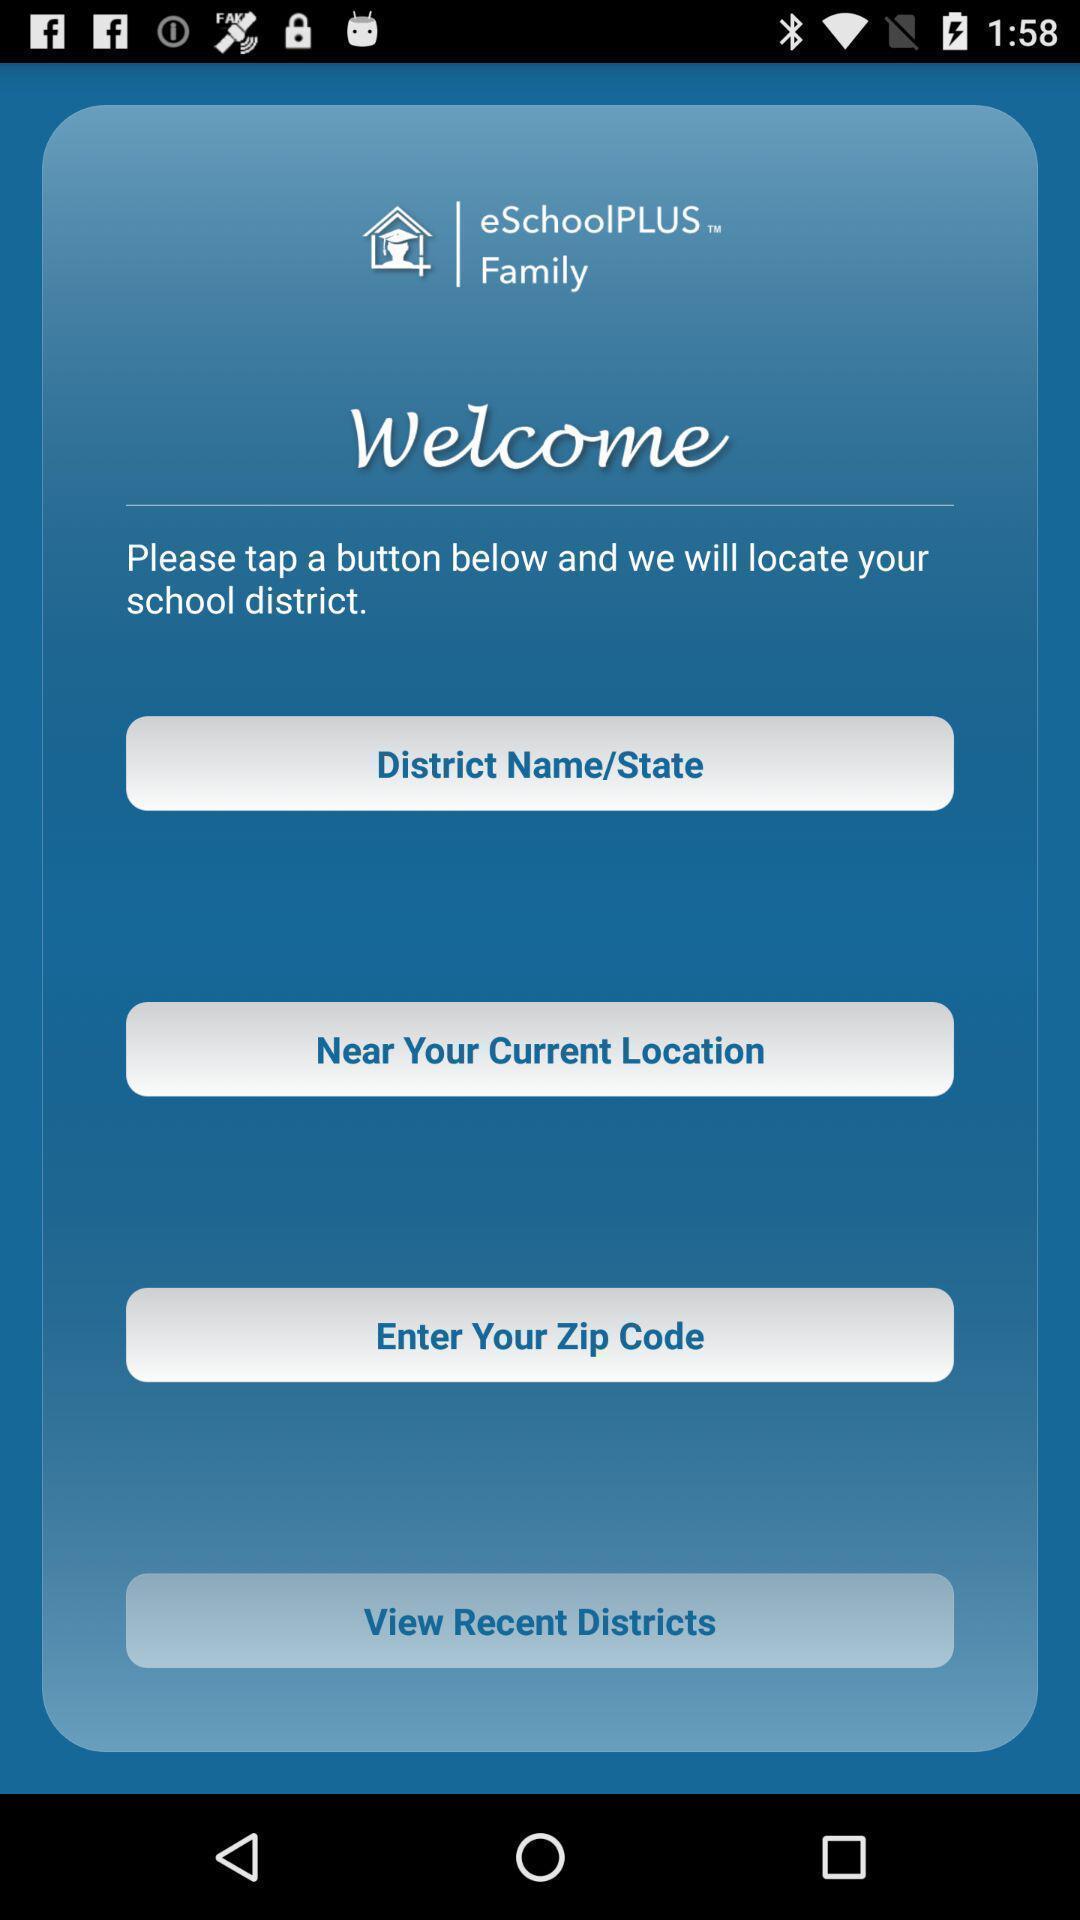Describe this image in words. Welcome page with location details in a family app. 